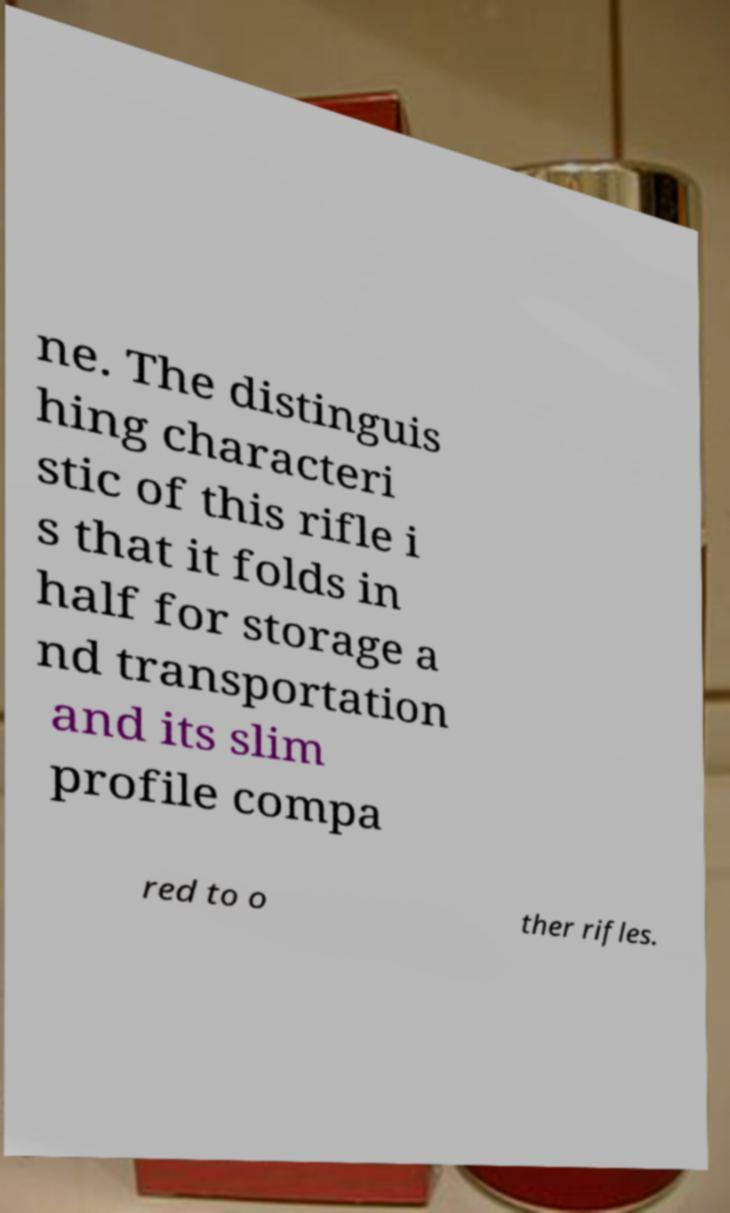I need the written content from this picture converted into text. Can you do that? ne. The distinguis hing characteri stic of this rifle i s that it folds in half for storage a nd transportation and its slim profile compa red to o ther rifles. 